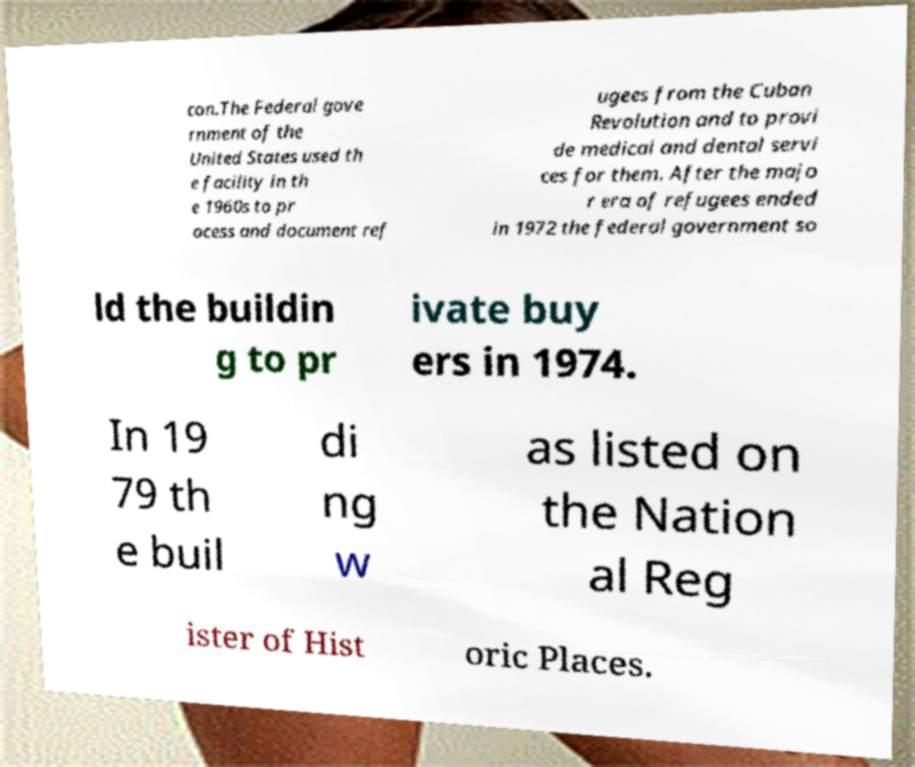For documentation purposes, I need the text within this image transcribed. Could you provide that? con.The Federal gove rnment of the United States used th e facility in th e 1960s to pr ocess and document ref ugees from the Cuban Revolution and to provi de medical and dental servi ces for them. After the majo r era of refugees ended in 1972 the federal government so ld the buildin g to pr ivate buy ers in 1974. In 19 79 th e buil di ng w as listed on the Nation al Reg ister of Hist oric Places. 